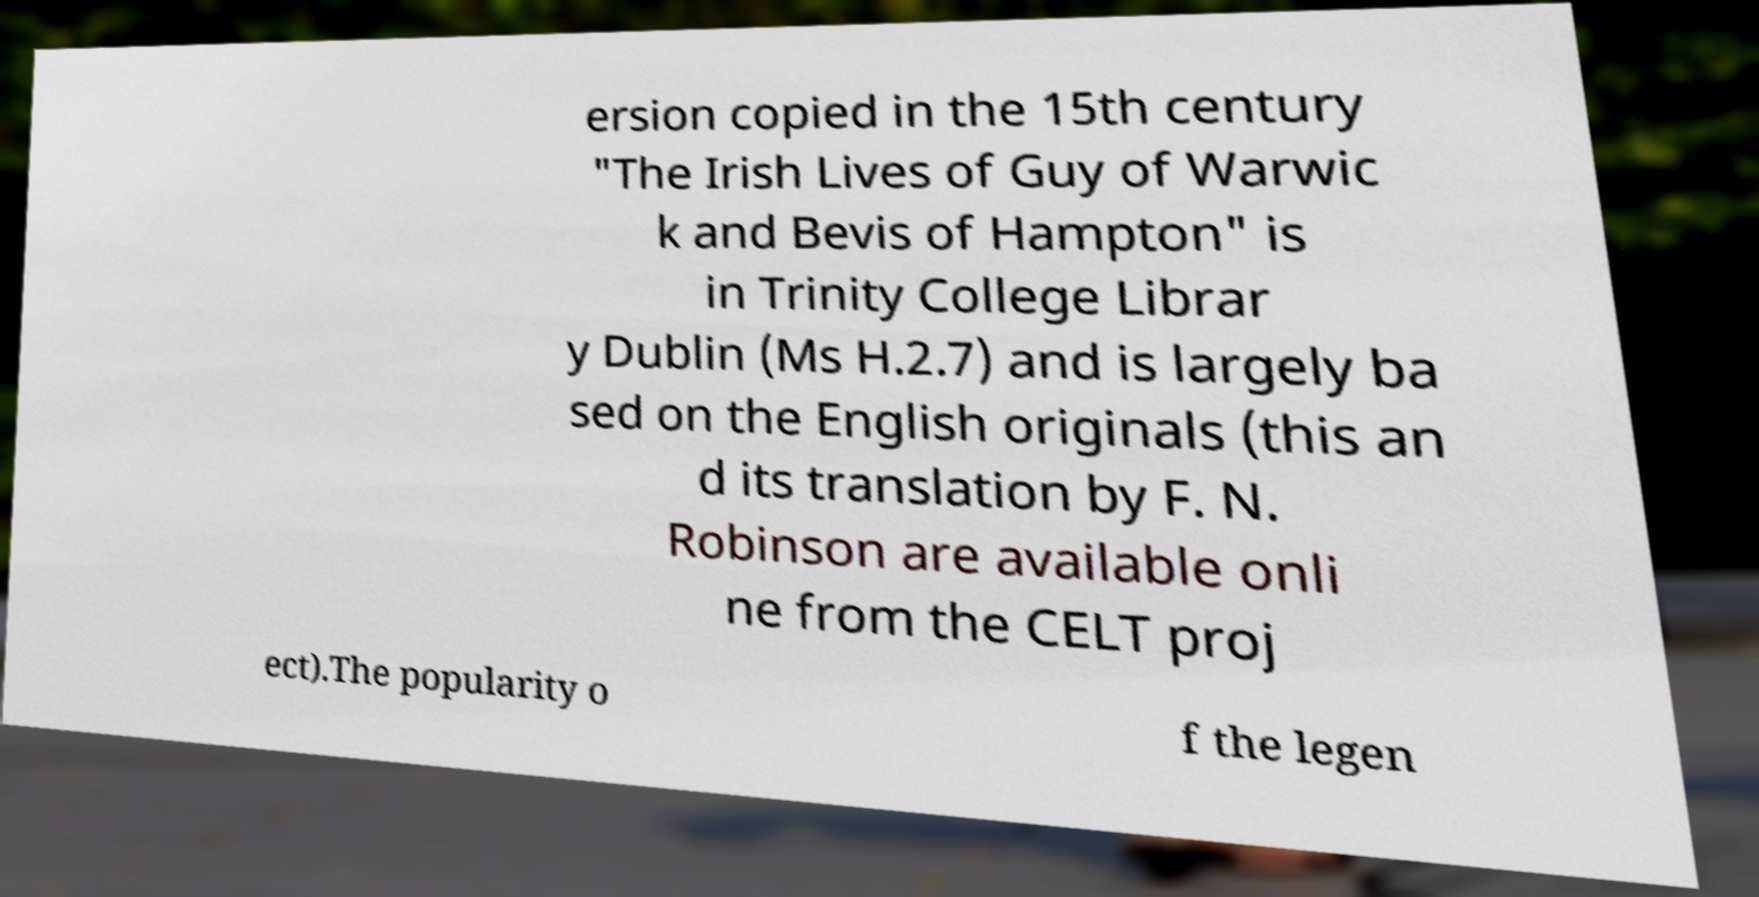I need the written content from this picture converted into text. Can you do that? ersion copied in the 15th century "The Irish Lives of Guy of Warwic k and Bevis of Hampton" is in Trinity College Librar y Dublin (Ms H.2.7) and is largely ba sed on the English originals (this an d its translation by F. N. Robinson are available onli ne from the CELT proj ect).The popularity o f the legen 